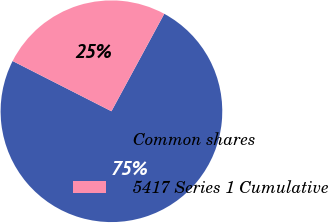Convert chart. <chart><loc_0><loc_0><loc_500><loc_500><pie_chart><fcel>Common shares<fcel>5417 Series 1 Cumulative<nl><fcel>74.58%<fcel>25.42%<nl></chart> 